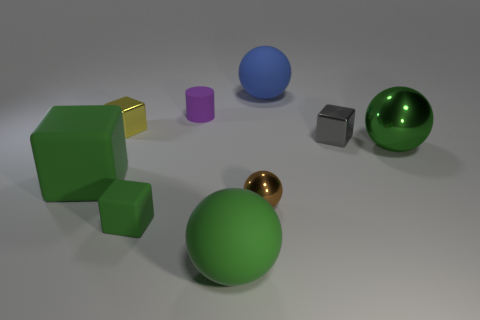What is the material of the tiny purple cylinder? rubber 